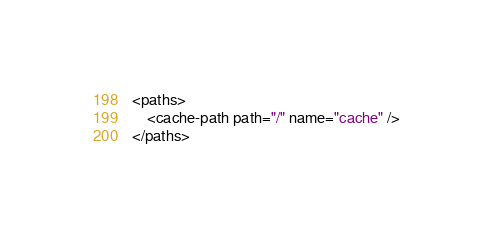Convert code to text. <code><loc_0><loc_0><loc_500><loc_500><_XML_><paths>
    <cache-path path="/" name="cache" />
</paths></code> 